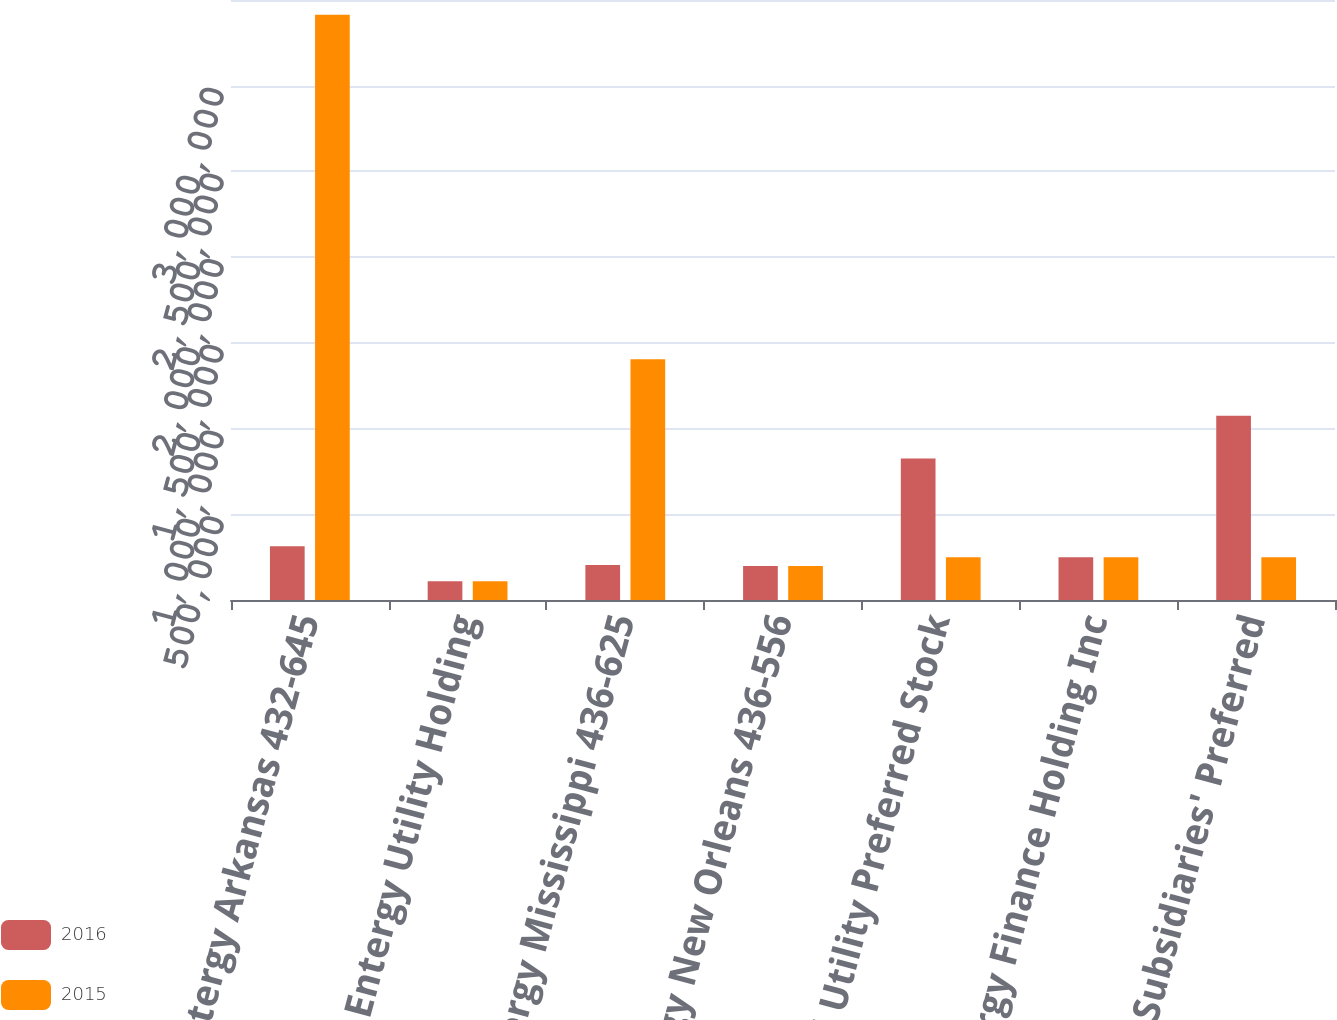<chart> <loc_0><loc_0><loc_500><loc_500><stacked_bar_chart><ecel><fcel>Entergy Arkansas 432-645<fcel>Entergy Utility Holding<fcel>Entergy Mississippi 436-625<fcel>Entergy New Orleans 436-556<fcel>Total Utility Preferred Stock<fcel>Entergy Finance Holding Inc<fcel>Total Subsidiaries' Preferred<nl><fcel>2016<fcel>313500<fcel>110000<fcel>203807<fcel>197798<fcel>825105<fcel>250000<fcel>1.0751e+06<nl><fcel>2015<fcel>3.4135e+06<fcel>110000<fcel>1.40381e+06<fcel>197798<fcel>250000<fcel>250000<fcel>250000<nl></chart> 